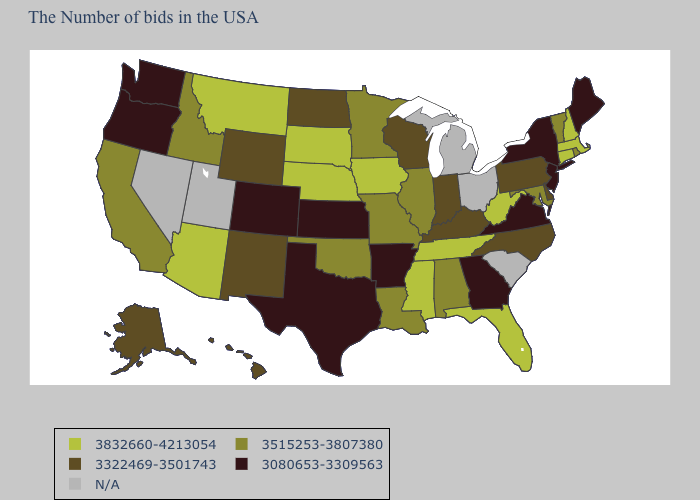What is the value of South Dakota?
Keep it brief. 3832660-4213054. Name the states that have a value in the range 3322469-3501743?
Concise answer only. Delaware, Pennsylvania, North Carolina, Kentucky, Indiana, Wisconsin, North Dakota, Wyoming, New Mexico, Alaska, Hawaii. What is the value of Nebraska?
Write a very short answer. 3832660-4213054. What is the value of Kentucky?
Be succinct. 3322469-3501743. What is the highest value in states that border Maryland?
Answer briefly. 3832660-4213054. Which states have the lowest value in the USA?
Answer briefly. Maine, New York, New Jersey, Virginia, Georgia, Arkansas, Kansas, Texas, Colorado, Washington, Oregon. Name the states that have a value in the range 3080653-3309563?
Concise answer only. Maine, New York, New Jersey, Virginia, Georgia, Arkansas, Kansas, Texas, Colorado, Washington, Oregon. Does Maryland have the lowest value in the USA?
Keep it brief. No. What is the value of Oklahoma?
Quick response, please. 3515253-3807380. What is the highest value in the USA?
Be succinct. 3832660-4213054. What is the highest value in the South ?
Answer briefly. 3832660-4213054. What is the value of Louisiana?
Quick response, please. 3515253-3807380. What is the lowest value in the South?
Quick response, please. 3080653-3309563. 